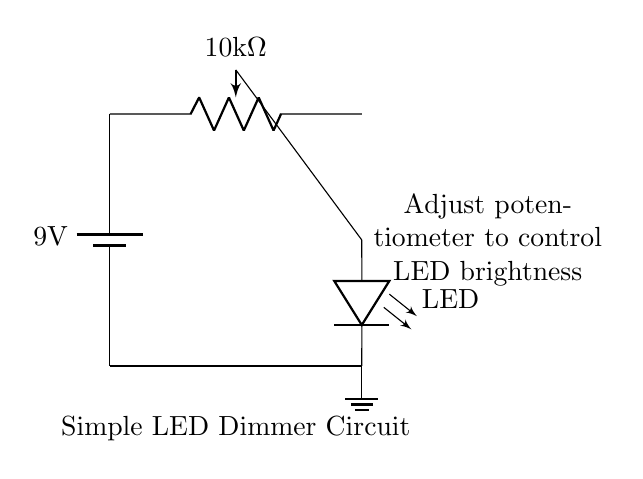What is the type of battery used in this circuit? The battery shown in the circuit diagram is labeled as a 9V battery.
Answer: 9V What is the resistance value of the potentiometer? The circuit diagram indicates that the potentiometer has a resistance value of 10 kilohms.
Answer: 10 kilohm How is the LED connected in this circuit? The LED is connected in series with the wiper of the potentiometer, allowing for variable brightness based on the resistance adjusted.
Answer: In series What happens when the potentiometer is adjusted to a lower resistance? Lowering the resistance of the potentiometer allows more current to flow through the LED, resulting in increased brightness.
Answer: Increased brightness What is the purpose of the ground in this circuit? The ground connection provides a reference point for the voltage in the circuit, completing the circuit path for current flow.
Answer: Reference point How does the potentiometer affect the LED's brightness? The potentiometer adjusts the resistance, which changes the current flowing through the LED, directly affecting its brightness.
Answer: It adjusts current 